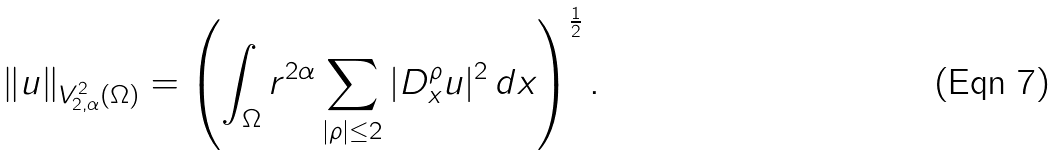Convert formula to latex. <formula><loc_0><loc_0><loc_500><loc_500>\| u \| _ { V ^ { 2 } _ { 2 , \alpha } ( \Omega ) } = \left ( \int _ { \Omega } r ^ { 2 \alpha } \sum _ { | \rho | \leq 2 } | D _ { x } ^ { \rho } u | ^ { 2 } \, d x \right ) ^ { \frac { 1 } { 2 } } .</formula> 